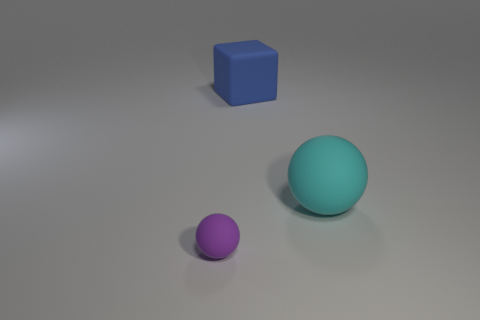Add 2 large matte things. How many objects exist? 5 Subtract 1 purple spheres. How many objects are left? 2 Subtract all balls. How many objects are left? 1 Subtract all tiny balls. Subtract all small purple spheres. How many objects are left? 1 Add 3 tiny rubber things. How many tiny rubber things are left? 4 Add 3 green matte spheres. How many green matte spheres exist? 3 